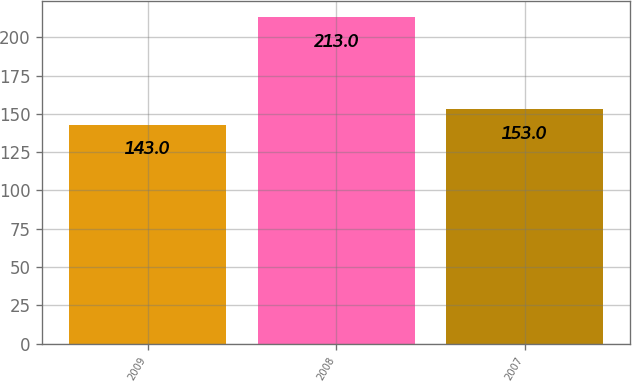Convert chart. <chart><loc_0><loc_0><loc_500><loc_500><bar_chart><fcel>2009<fcel>2008<fcel>2007<nl><fcel>143<fcel>213<fcel>153<nl></chart> 